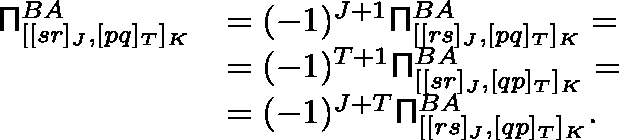Convert formula to latex. <formula><loc_0><loc_0><loc_500><loc_500>\begin{array} { r l } { \Pi _ { [ [ s r ] _ { J } , [ p q ] _ { T } ] _ { K } } ^ { B A } } & { = ( - 1 ) ^ { J + 1 } \Pi _ { [ [ r s ] _ { J } , [ p q ] _ { T } ] _ { K } } ^ { B A } = } \\ & { = ( - 1 ) ^ { T + 1 } \Pi _ { [ [ s r ] _ { J } , [ q p ] _ { T } ] _ { K } } ^ { B A } = } \\ & { = ( - 1 ) ^ { J + T } \Pi _ { [ [ r s ] _ { J } , [ q p ] _ { T } ] _ { K } } ^ { B A } . } \end{array}</formula> 